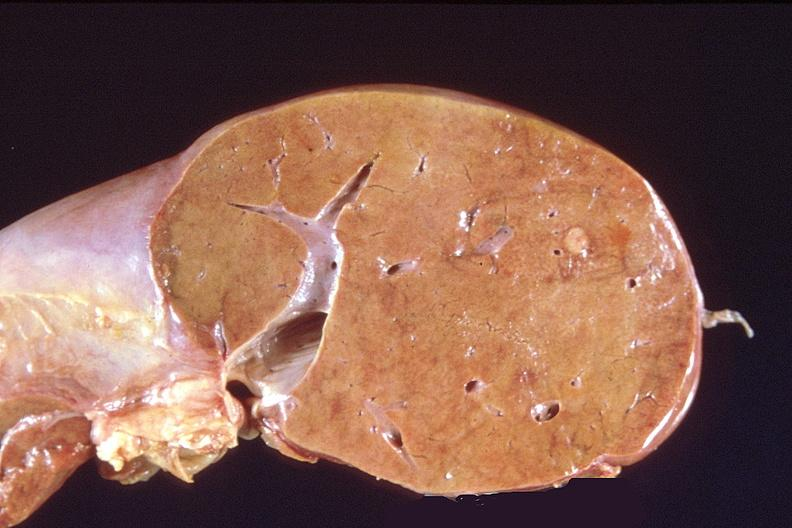what is present?
Answer the question using a single word or phrase. Hepatobiliary 